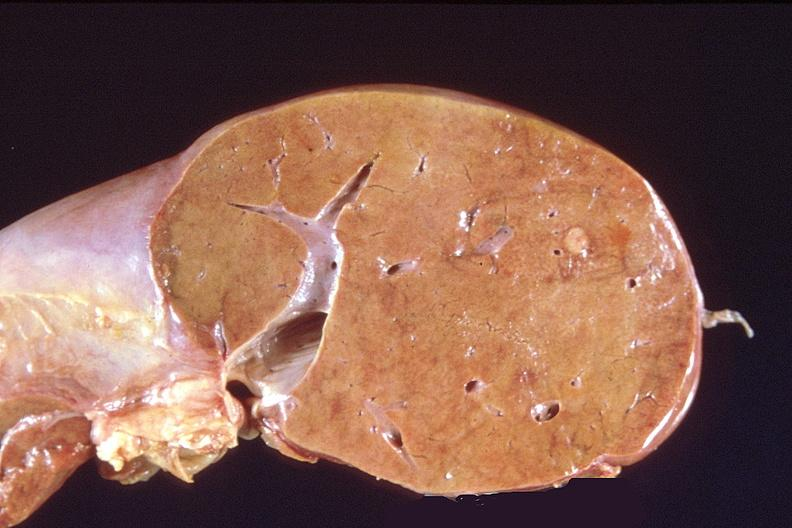what is present?
Answer the question using a single word or phrase. Hepatobiliary 